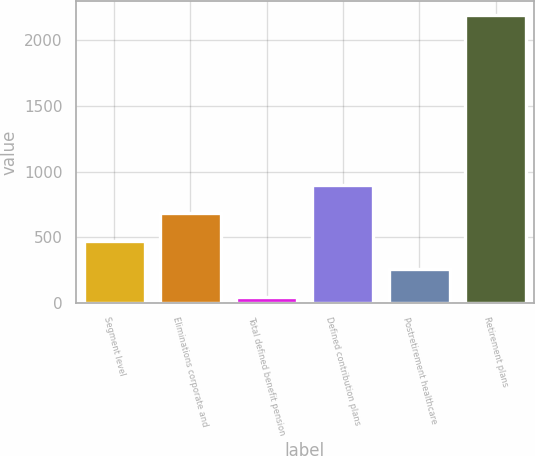Convert chart. <chart><loc_0><loc_0><loc_500><loc_500><bar_chart><fcel>Segment level<fcel>Eliminations corporate and<fcel>Total defined benefit pension<fcel>Defined contribution plans<fcel>Postretirement healthcare<fcel>Retirement plans<nl><fcel>470.8<fcel>685.7<fcel>41<fcel>900.6<fcel>255.9<fcel>2190<nl></chart> 